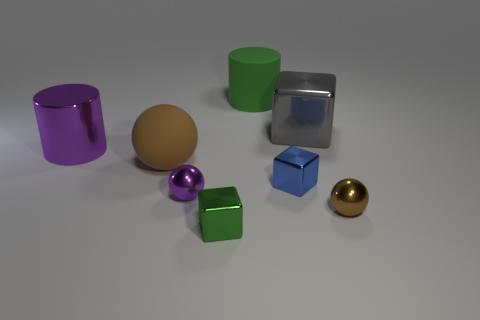Subtract all tiny cubes. How many cubes are left? 1 Add 2 matte cubes. How many objects exist? 10 Subtract all purple spheres. How many spheres are left? 2 Subtract 2 cubes. How many cubes are left? 1 Add 3 big rubber spheres. How many big rubber spheres are left? 4 Add 5 small purple shiny spheres. How many small purple shiny spheres exist? 6 Subtract 1 purple cylinders. How many objects are left? 7 Subtract all cylinders. How many objects are left? 6 Subtract all cyan spheres. Subtract all gray cylinders. How many spheres are left? 3 Subtract all red cubes. How many purple cylinders are left? 1 